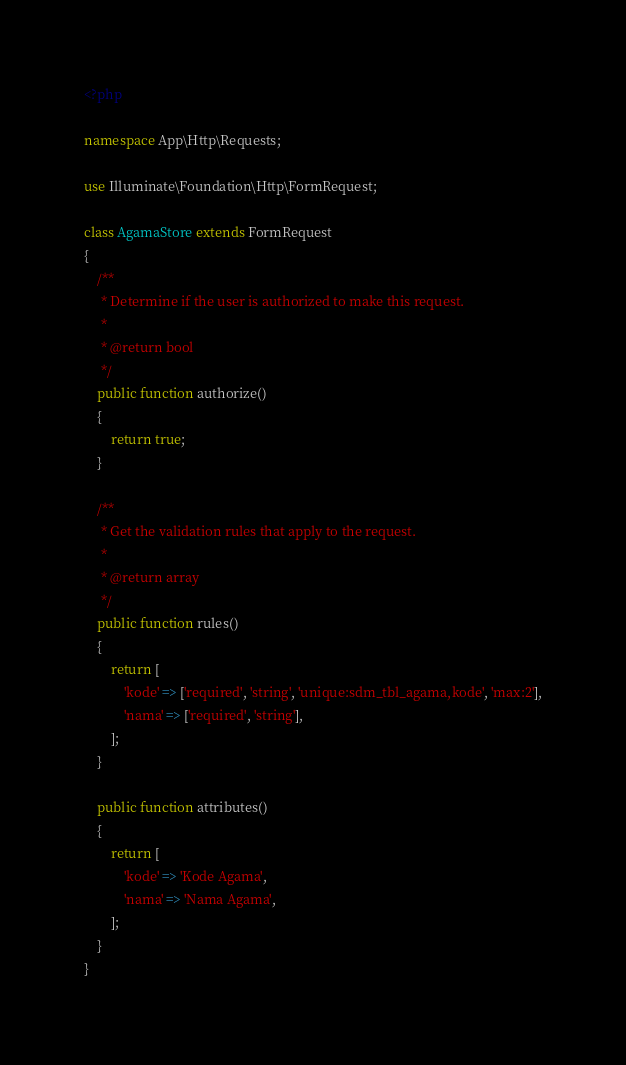<code> <loc_0><loc_0><loc_500><loc_500><_PHP_><?php

namespace App\Http\Requests;

use Illuminate\Foundation\Http\FormRequest;

class AgamaStore extends FormRequest
{
    /**
     * Determine if the user is authorized to make this request.
     *
     * @return bool
     */
    public function authorize()
    {
        return true;
    }

    /**
     * Get the validation rules that apply to the request.
     *
     * @return array
     */
    public function rules()
    {
        return [
            'kode' => ['required', 'string', 'unique:sdm_tbl_agama,kode', 'max:2'],
            'nama' => ['required', 'string'],
        ];
    }

    public function attributes()
    {
        return [
            'kode' => 'Kode Agama',
            'nama' => 'Nama Agama',
        ];
    }
}
</code> 